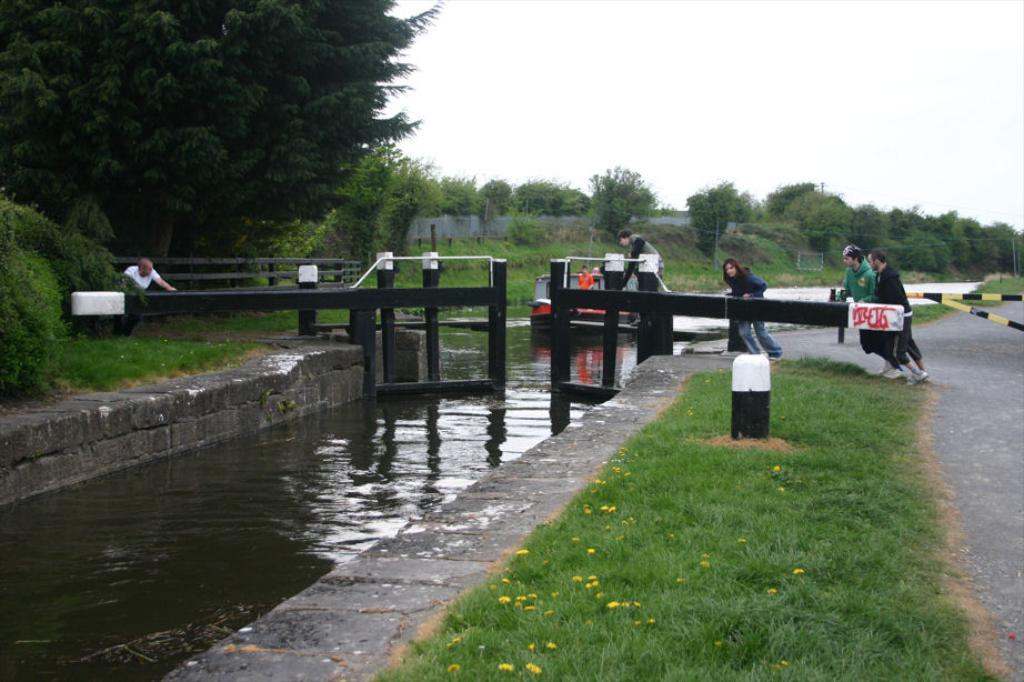What type of plants can be seen in the image? There are flowers and grass in the image. What can be seen on the ground in the image? There is grass visible in the image. What are the people in the image doing? The people in the image are on the road. What is the main mode of transportation in the image? There is a boat in the image, which is a mode of transportation. What is the body of water in the image used for? The water visible in the image is likely used for boating, as there is a boat present. What type of barrier is present in the image? There is a fence in the image. What type of structure is present in the image? There are rods in the image, which could be part of a structure. What is visible in the background of the image? In the background of the image, there is a wall, trees, and the sky. What type of disease is affecting the flowers in the image? There is no indication of any disease affecting the flowers in the image. Can you tell me how many clovers are present in the image? There is no mention of clover in the image; it features flowers and grass. 